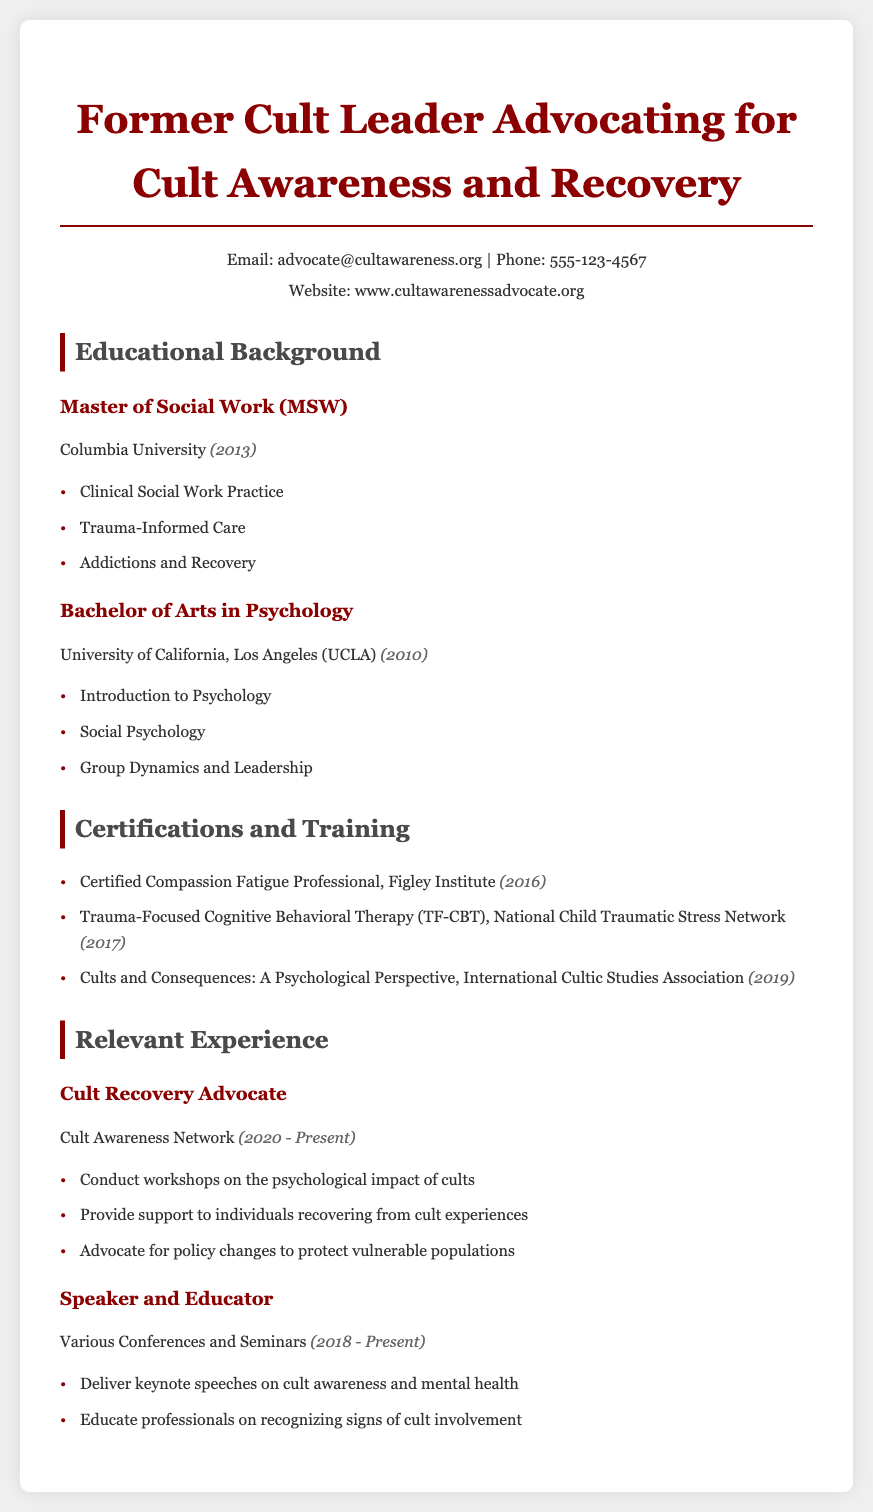What degree was obtained from Columbia University? The document states that a Master of Social Work (MSW) was obtained from Columbia University.
Answer: Master of Social Work (MSW) What year was the Bachelor of Arts in Psychology awarded? According to the document, the Bachelor of Arts in Psychology was awarded in 2010.
Answer: 2010 Which certification was earned in 2016? The document lists "Certified Compassion Fatigue Professional" as the certification earned in 2016.
Answer: Certified Compassion Fatigue Professional What training focuses on cults from a psychological perspective? The document mentions "Cults and Consequences: A Psychological Perspective" as the relevant training focusing on cults in 2019.
Answer: Cults and Consequences: A Psychological Perspective How many years of experience does the Cult Recovery Advocate role encompass? The document specifies that the Cult Recovery Advocate has been in the role since 2020 to the present, indicating it covers 3 years as of 2023.
Answer: 3 years What is the main focus of the workshops conducted by the Cult Recovery Advocate? The document states that the workshops focus on the psychological impact of cults.
Answer: Psychological impact of cults What type of education does this curriculum vitae represent? This document represents the educational background relevant to psychology, counseling, and social work.
Answer: Educational background in psychology, counseling, and social work What university did the individual attend for their undergraduate degree? The document indicates that the undergraduate degree was obtained from the University of California, Los Angeles (UCLA).
Answer: University of California, Los Angeles (UCLA) 